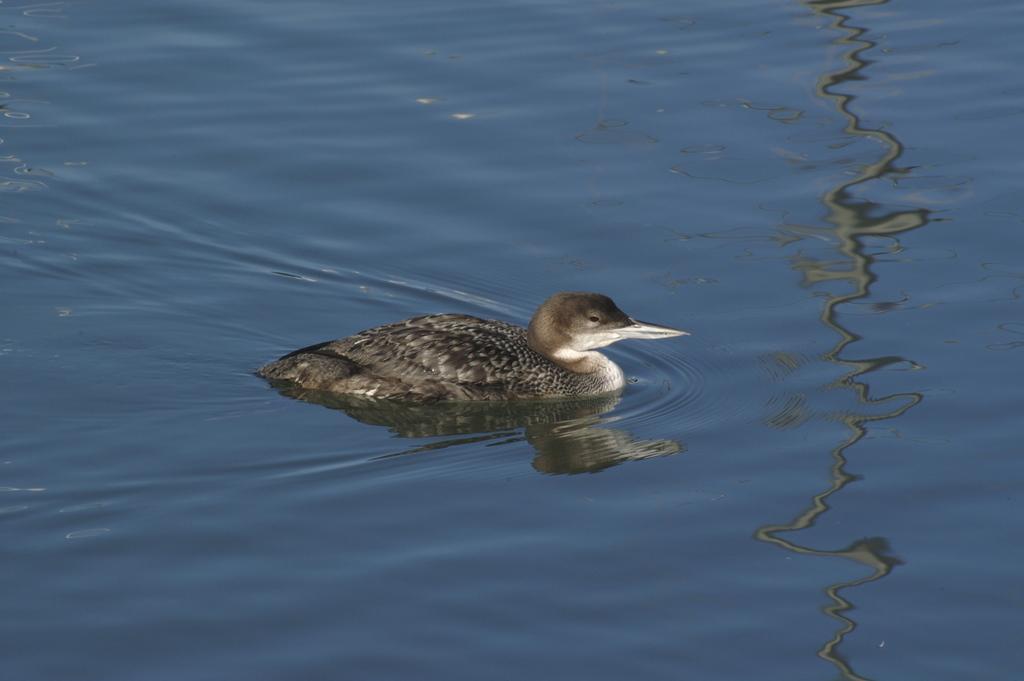Could you give a brief overview of what you see in this image? In this image we can see a bird in the water. 